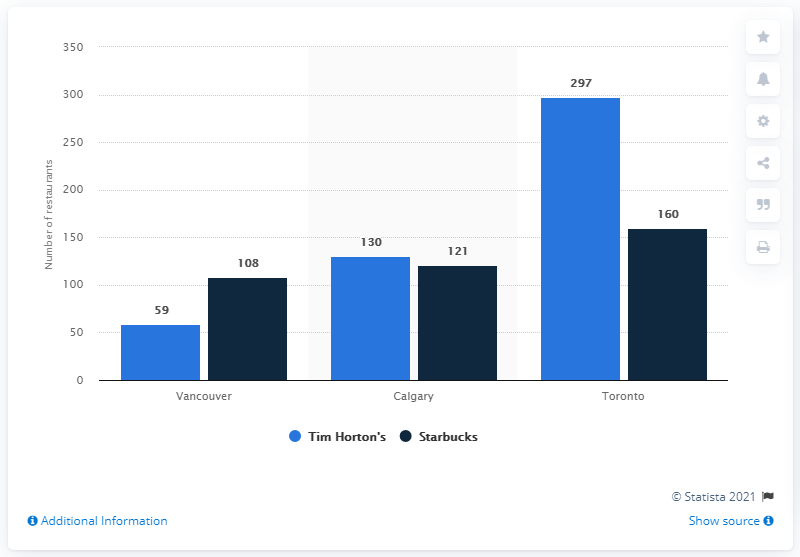Which city has the highest number of Tim Hortons according to this chart? Based on the chart, Toronto has the highest number of Tim Hortons locations, with a total of 297 outlets. It significantly surpasses Vancouver and Calgary in this regard. 